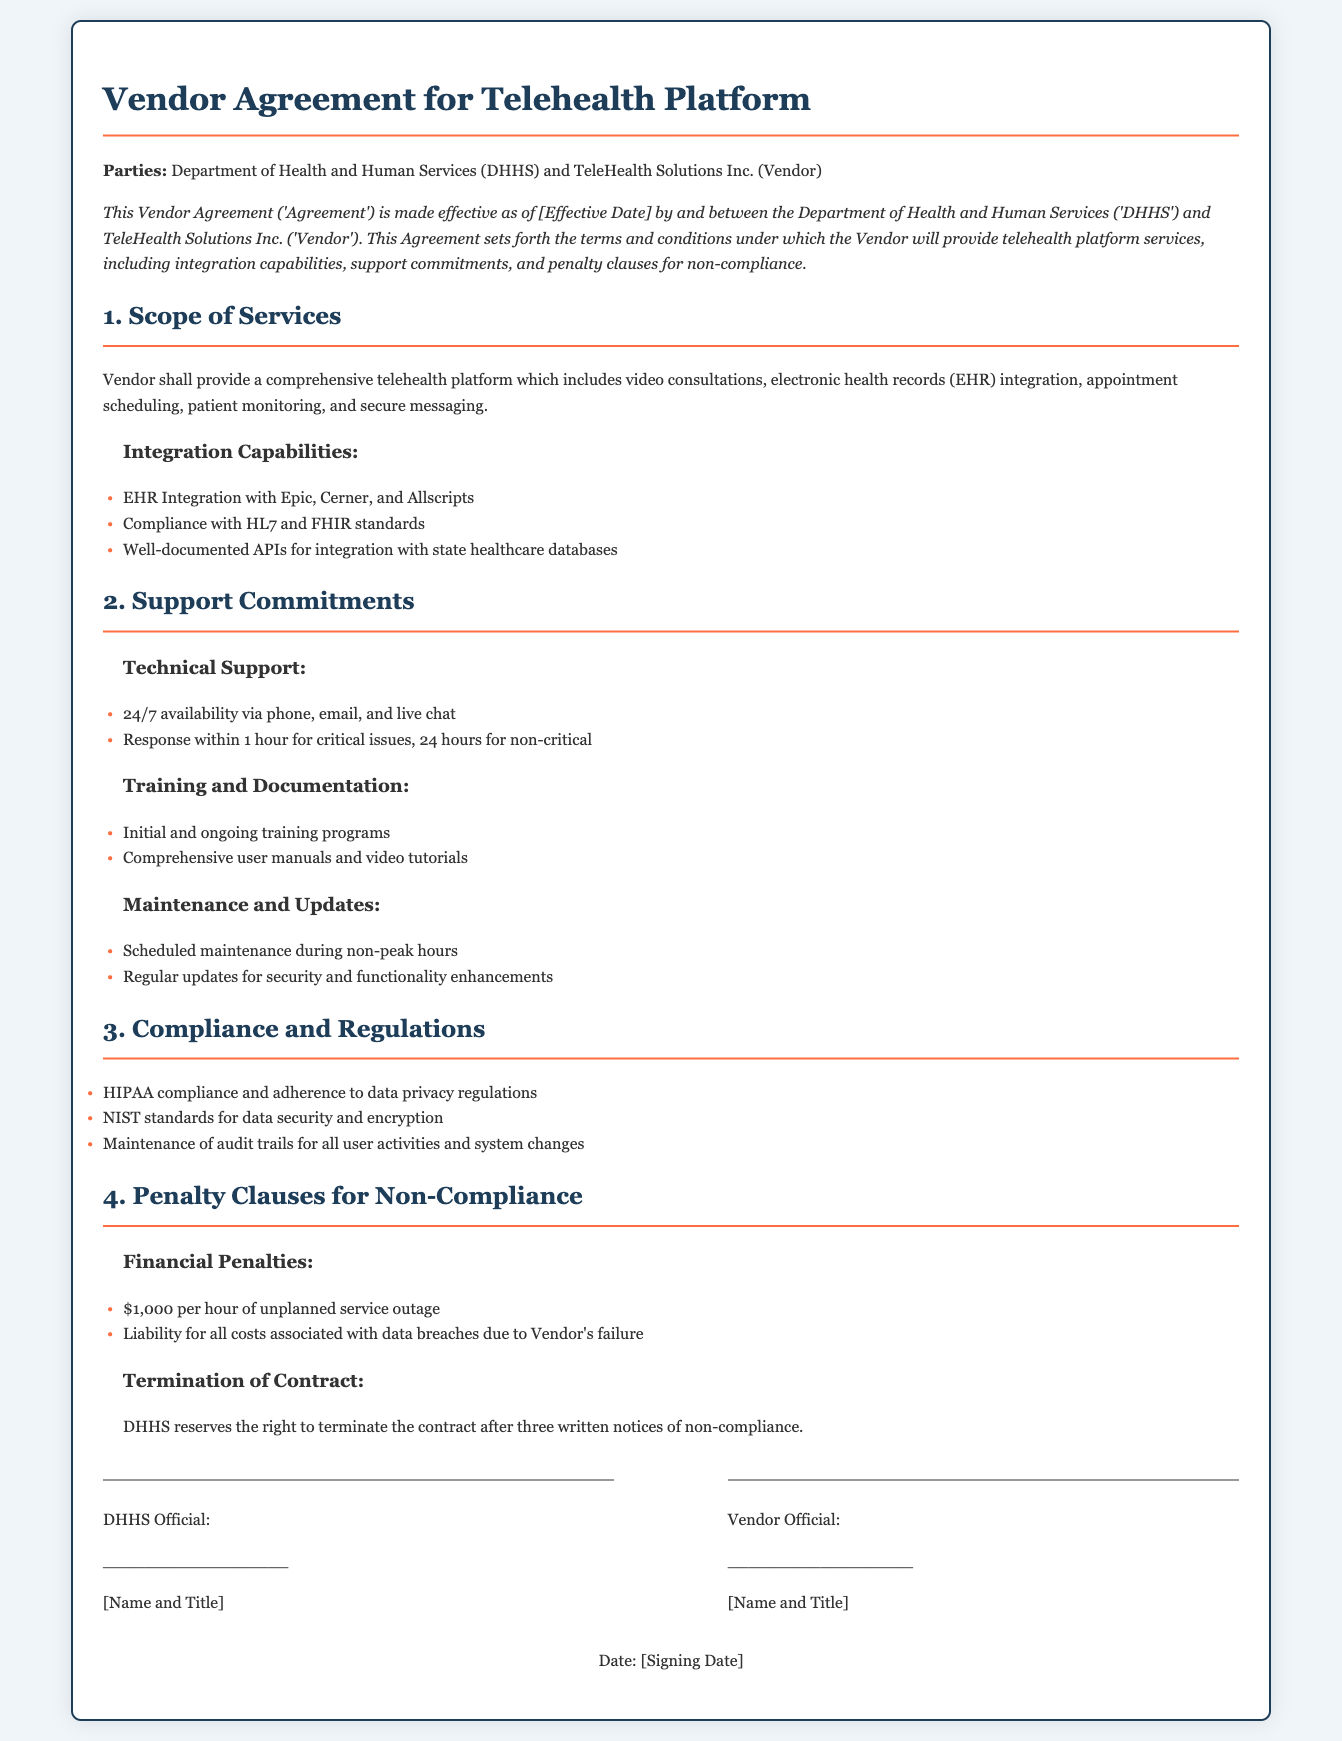What parties are involved in the agreement? The document specifies the parties involved as the Department of Health and Human Services (DHHS) and TeleHealth Solutions Inc. (Vendor).
Answer: DHHS and TeleHealth Solutions Inc What integration capabilities does the Vendor provide? The document lists specific integration capabilities including EHR integrations and standards compliance.
Answer: EHR Integration with Epic, Cerner, and Allscripts What is the penalty for an unplanned service outage? The document outlines a financial penalty amount for service outages which is explicitly stated.
Answer: $1,000 per hour What is the response time for critical issues? The document details the support commitments including response times for various issues.
Answer: 1 hour How many written notices of non-compliance are required for termination? The document specifies a number of notices needed before termination can occur.
Answer: Three written notices What types of support are included in the Vendor's commitments? The document describes several forms of support provided by the Vendor, categorizing support types.
Answer: 24/7 availability via phone, email, and live chat What compliance standard does the Vendor need to adhere to for data security? The document mentions a specific set of standards for data security compliance that the Vendor must follow.
Answer: NIST standards What does the Vendor need to maintain for user activities? The document states a requirement related to tracking user activities and changes.
Answer: Audit trails 